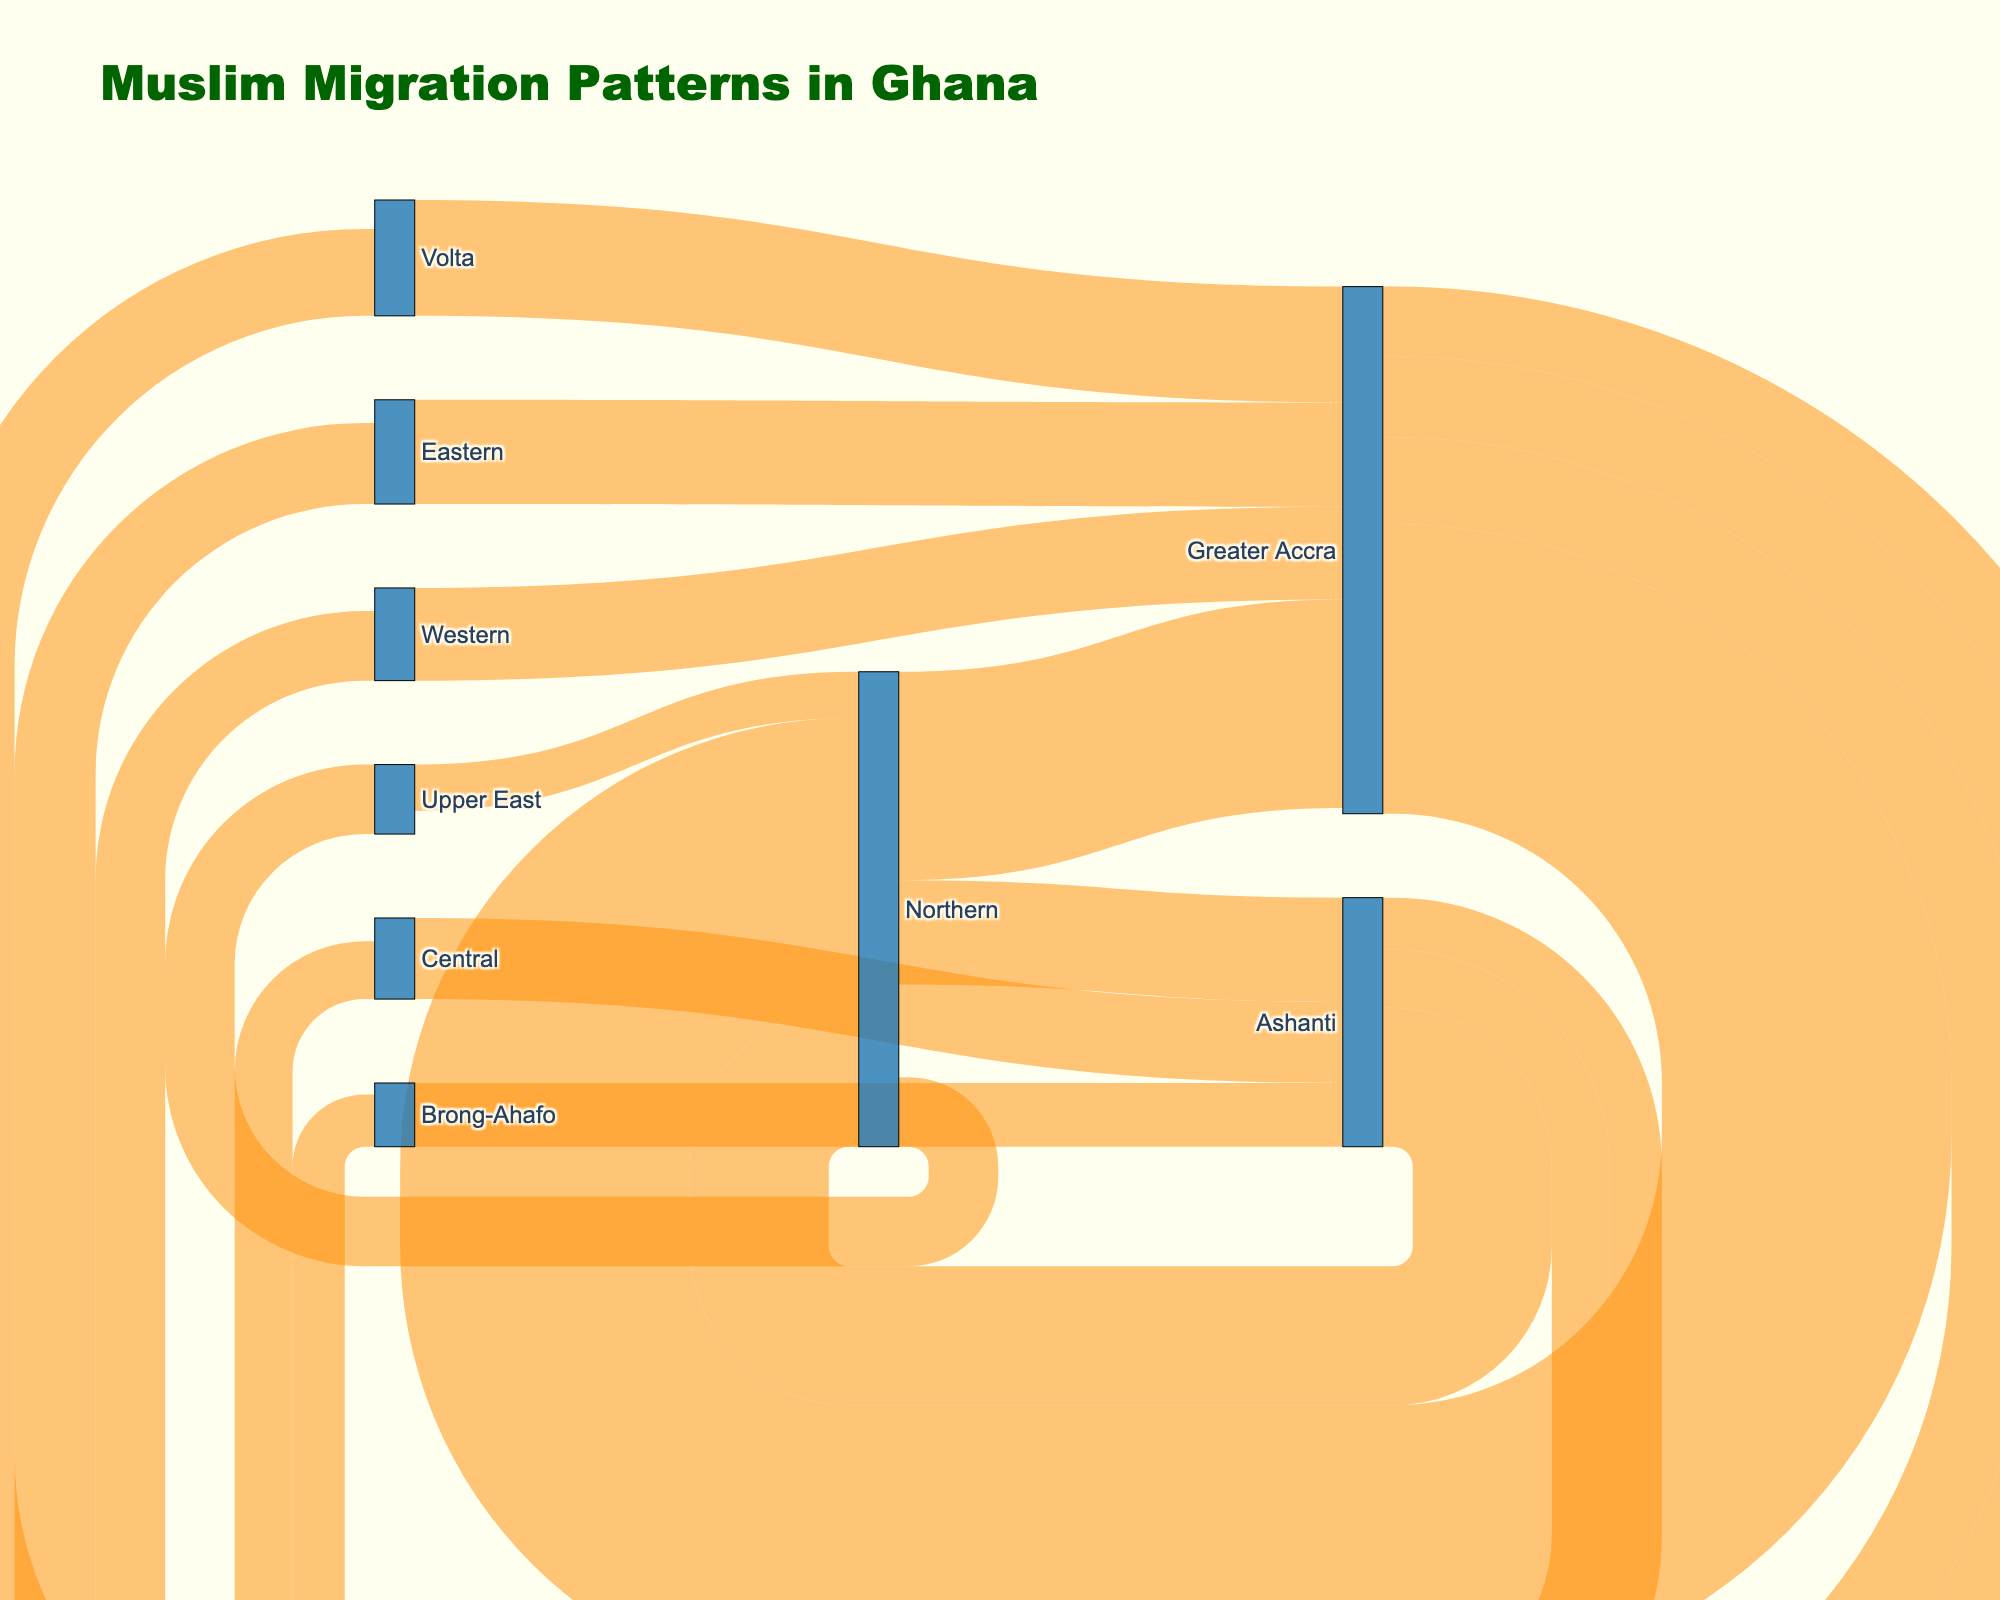Which region has the highest migration inflow to Greater Accra? Review the figure for regions connecting to Greater Accra and check the values of incoming flow. The highest inflow is from the Northern region with 2500.
Answer: Northern What is the total migration outflow from the Northern region? Identify all the outflow values from Northern. Add 2500 (to Greater Accra), 600 (to Upper East), and 900 (to Ashanti).
Answer: 4000 Among Ashanti, Central, and Northern, which region has the least migration inflow? Compare the migration inflow values to these regions. Ashanti (900 from Northern and 700 from Central), Central (500 from Ashanti), Northern (1800 from Greater Accra, 1200 from Ashanti, 900 from Ashanti). The lowest inflow is Central with 500.
Answer: Central Does Greater Accra have more migration inflow or outflow? Tally the inflow (2500 from Northern, 800 from Western, 1000 from Volta, 900 from Eastern) and outflow (1800 to Northern, 600 to Western, 750 to Volta, 700 to Eastern). The inflow sums to 5200 and the outflow sums to 3850.
Answer: Inflow How many regions have a migration inflow from Ashanti? Identify the regions as targets of Ashanti. Northern, Central, Brong-Ahafo are three regions that receive migration from Ashanti.
Answer: Three What is the difference in migration volume between Greater Accra to Northern and Northern to Greater Accra? Calculate the absolute difference between 2500 and 1800. The difference is 700.
Answer: 700 Which is the largest inter-regional migration flow shown in the figure? Examine all migration flow values and find the highest one. The maximum value is 2500 from Greater Accra to Northern.
Answer: Greater Accra to Northern From which region does Brong-Ahafo receive its migration inflow? Check the Sankey diagram to determine the source for Brong-Ahafo. The inflow is from Ashanti.
Answer: Ashanti What is the total migration outflow from Greater Accra? Sum the migration outflows: 1800 (to Northern), 600 (to Western), 750 (to Volta), 700 (to Eastern).
Answer: 3850 Which two regions have the bi-directional migration flow of 1000 or more? Identify pairs where the flow in both directions sums to 1000 or more. Greater Accra and Northern have 2500 -> Northern and 1800 -> Greater Accra, which exceeds 1000 in both directions.
Answer: Greater Accra and Northern 